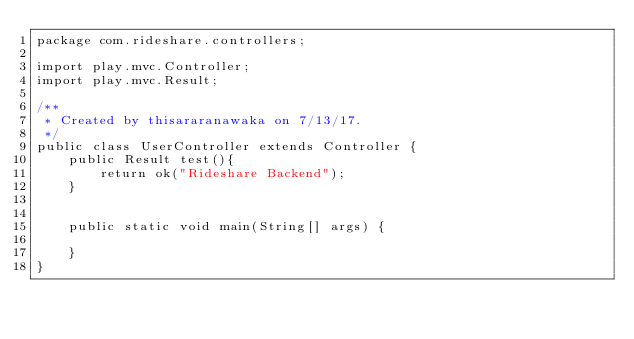Convert code to text. <code><loc_0><loc_0><loc_500><loc_500><_Java_>package com.rideshare.controllers;

import play.mvc.Controller;
import play.mvc.Result;

/**
 * Created by thisararanawaka on 7/13/17.
 */
public class UserController extends Controller {
    public Result test(){
        return ok("Rideshare Backend");
    }


    public static void main(String[] args) {

    }
}
</code> 